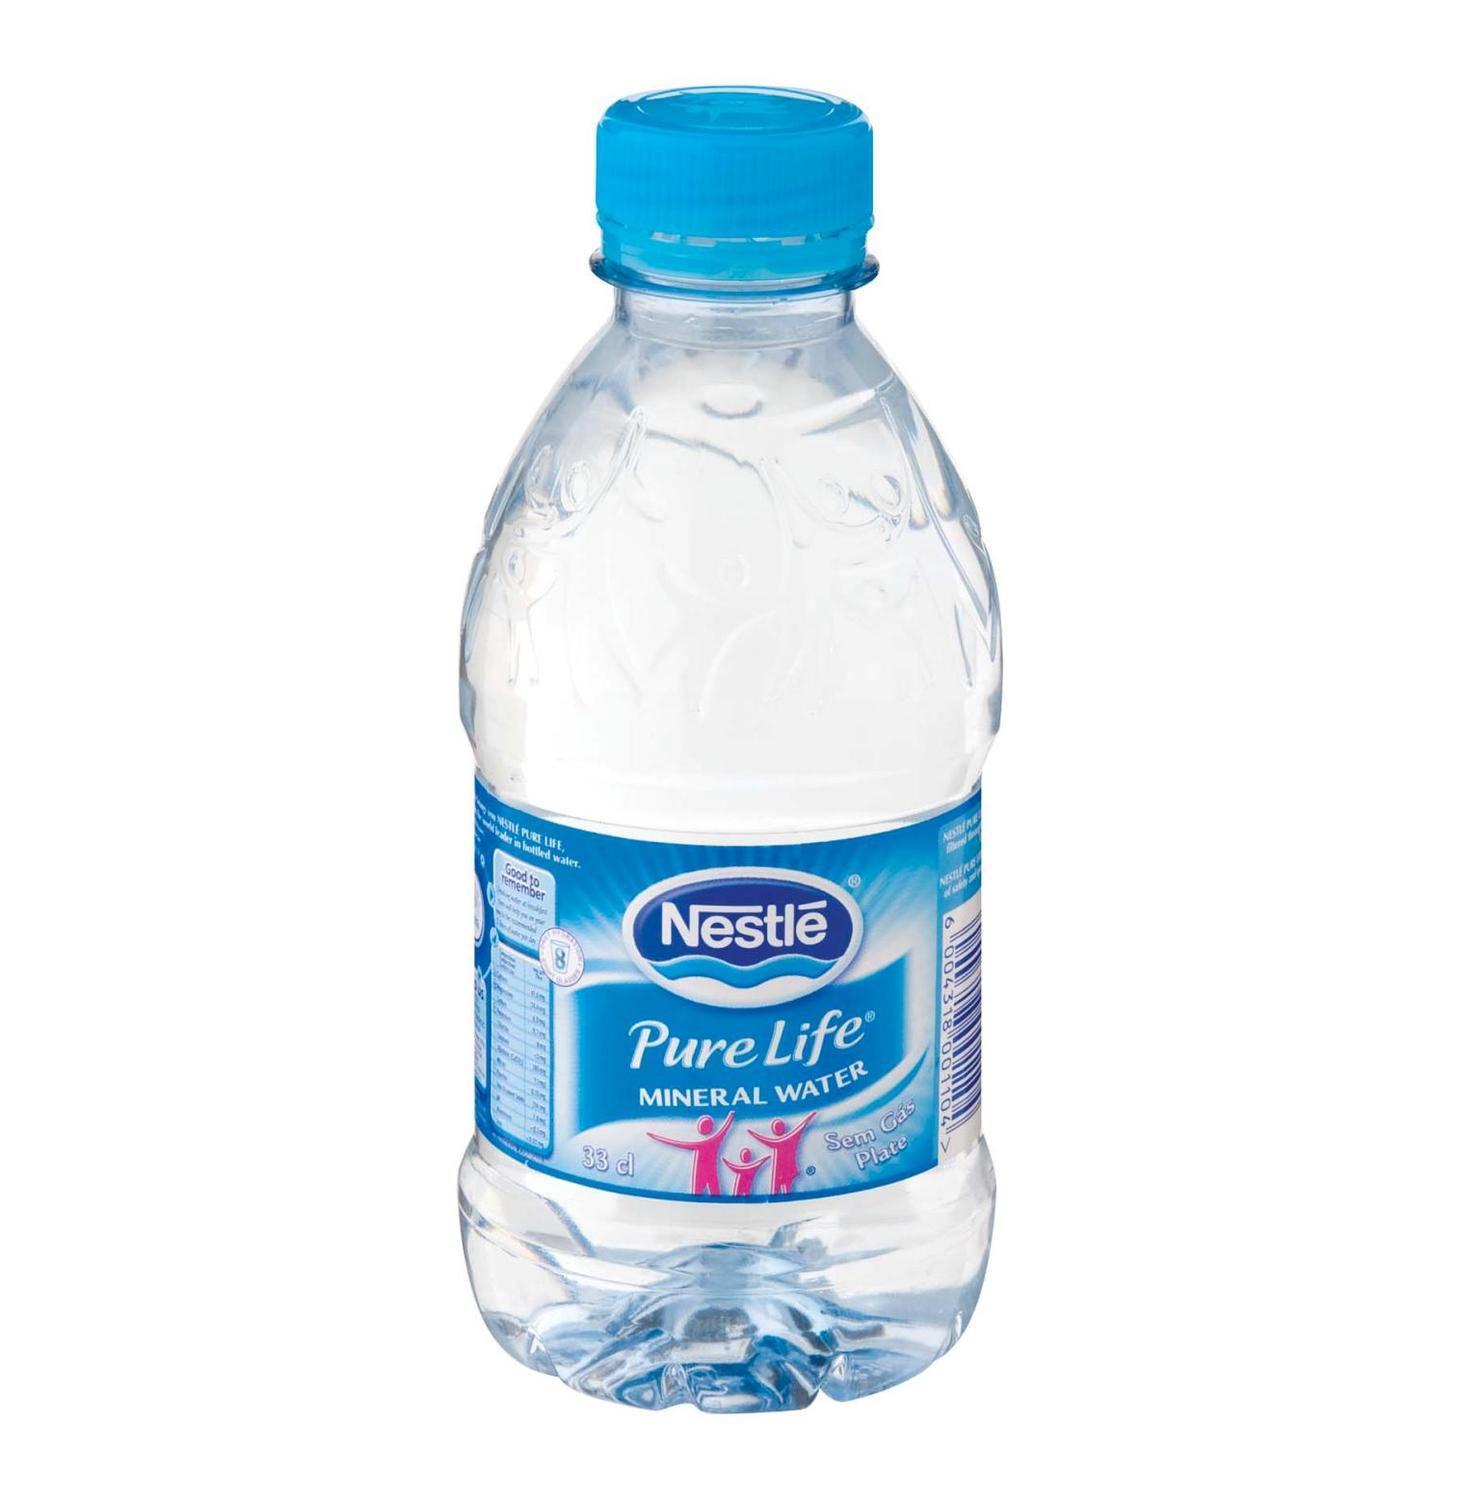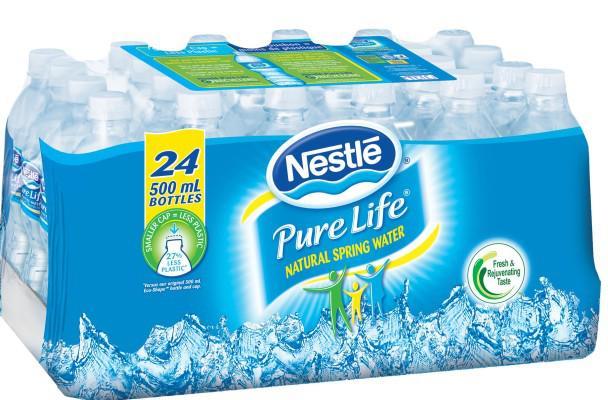The first image is the image on the left, the second image is the image on the right. For the images shown, is this caption "There is exactly one water bottle in the image on the left." true? Answer yes or no. Yes. The first image is the image on the left, the second image is the image on the right. For the images displayed, is the sentence "An image shows exactly one water bottle." factually correct? Answer yes or no. Yes. 